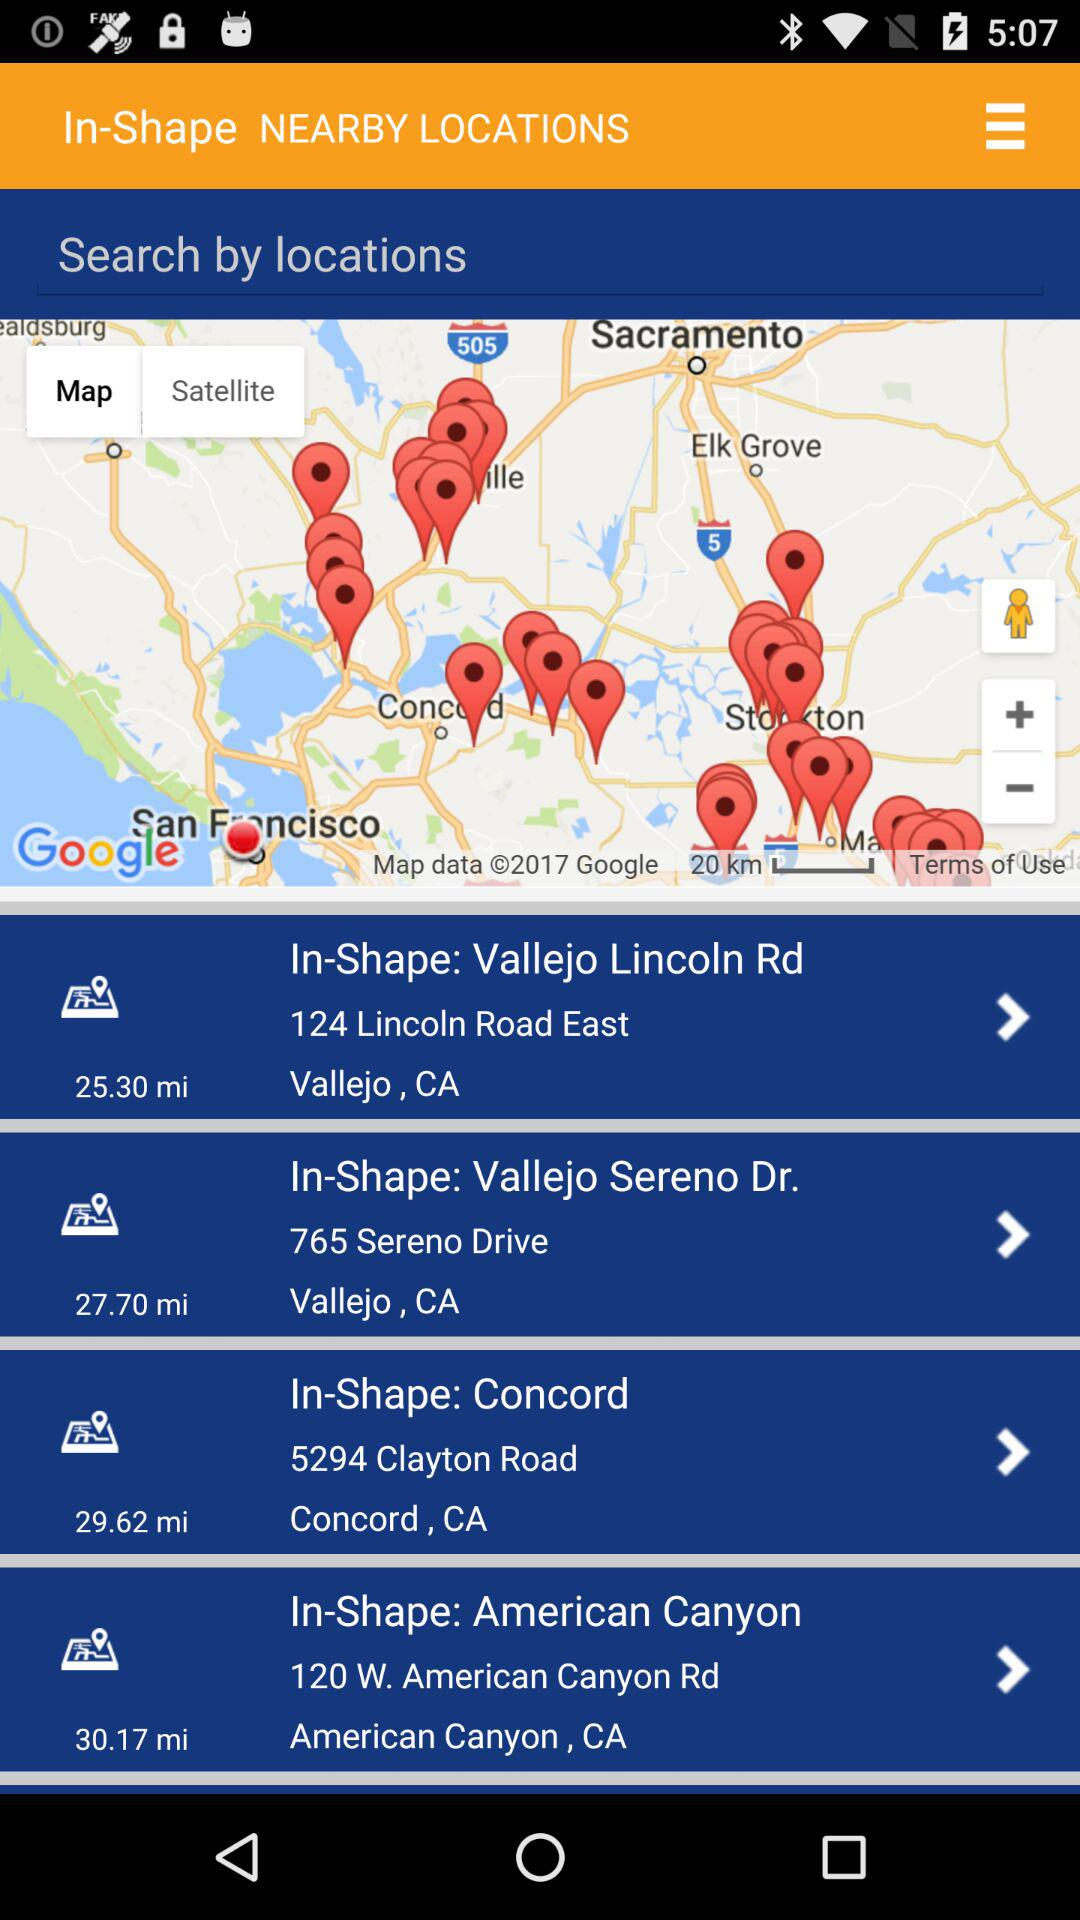What is the distance of the In-Shape Vallejo Lincoln Road? The distance is 25.30 miles. 